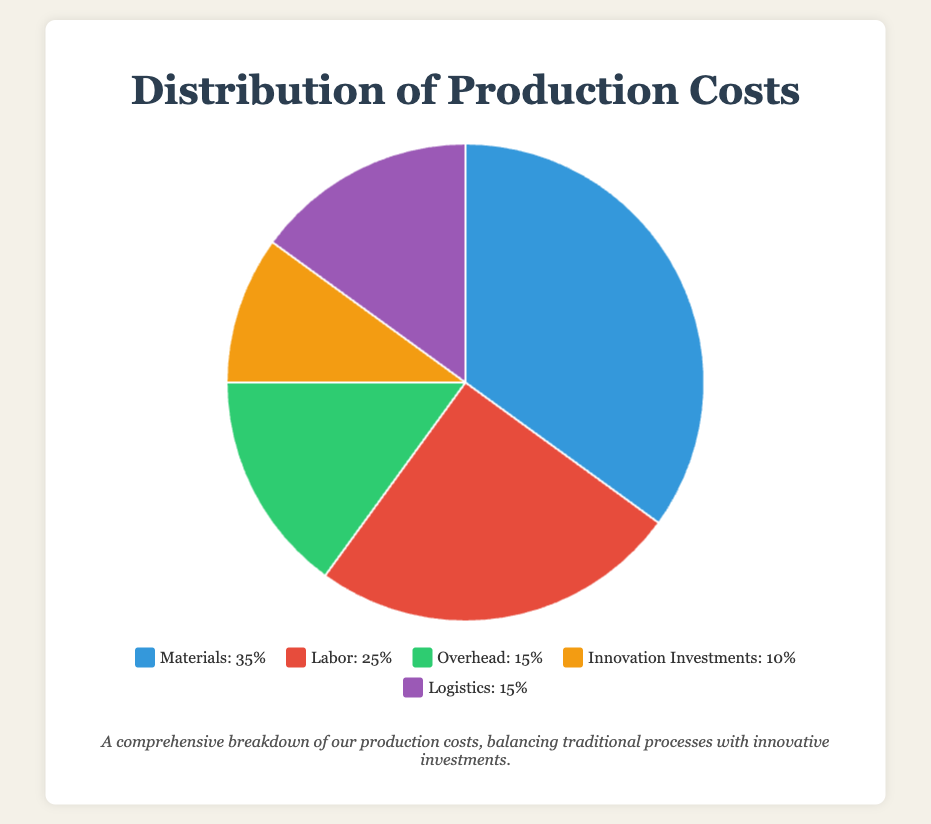What's the largest cost category? By looking at the data, the largest slice in the pie chart represents the Materials category, which accounts for 35% of the costs.
Answer: Materials How much more is spent on Materials compared to Innovation Investments? Materials account for 35% of the costs while Innovation Investments account for 10%. The difference is 35% - 10% = 25%.
Answer: 25% Which two categories have the same cost percentage? From the pie chart, both Overhead and Logistics have the same percentage, each accounting for 15% of the costs.
Answer: Overhead and Logistics What is the combined cost percentage for Labor and Logistics? Labor accounts for 25% and Logistics for 15%. The combined percentage is 25% + 15% = 40%.
Answer: 40% Which cost category is represented by the color red? According to the visual information, the red segment in the pie chart represents Labor, which accounts for 25% of the costs.
Answer: Labor How much more is spent on Labor than Overhead? Labor accounts for 25% of the costs and Overhead accounts for 15%. The difference is 25% - 15% = 10%.
Answer: 10% What is the average cost percentage of the three smallest categories? The three smallest categories are Overhead (15%), Innovation Investments (10%), and Logistics (15%). The average is (15% + 10% + 15%) / 3 = 40% / 3 ≈ 13.33%.
Answer: 13.33% If materials costs were reduced by 5%, what would the new percentage be? Currently, Materials account for 35%. If reduced by 5%, the new percentage is 35% - 5% = 30%.
Answer: 30% What proportion of the costs are constituted by categories other than Materials? Materials account for 35%, so the remaining proportion is 100% - 35% = 65%.
Answer: 65% How does the percentage for Innovation Investments compare to Labor and Overhead combined? Innovation Investments account for 10%. Labor and Overhead combined account for 25% + 15% = 40%. Thus, Innovation Investments (10%) are 30% less than Labor and Overhead combined (40%).
Answer: 30% less 